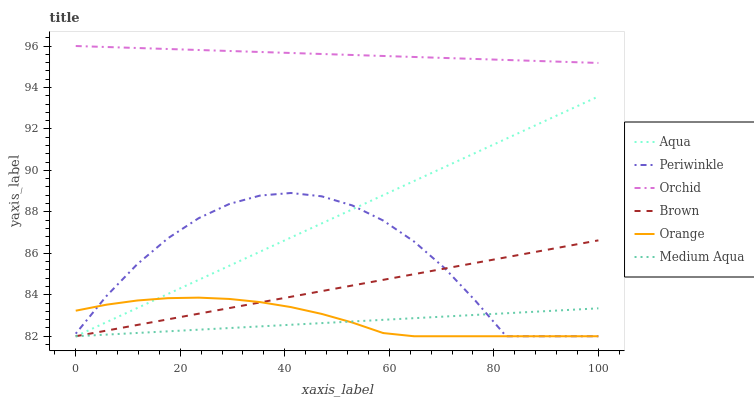Does Medium Aqua have the minimum area under the curve?
Answer yes or no. Yes. Does Orchid have the maximum area under the curve?
Answer yes or no. Yes. Does Aqua have the minimum area under the curve?
Answer yes or no. No. Does Aqua have the maximum area under the curve?
Answer yes or no. No. Is Medium Aqua the smoothest?
Answer yes or no. Yes. Is Periwinkle the roughest?
Answer yes or no. Yes. Is Aqua the smoothest?
Answer yes or no. No. Is Aqua the roughest?
Answer yes or no. No. Does Orchid have the lowest value?
Answer yes or no. No. Does Aqua have the highest value?
Answer yes or no. No. Is Brown less than Orchid?
Answer yes or no. Yes. Is Orchid greater than Aqua?
Answer yes or no. Yes. Does Brown intersect Orchid?
Answer yes or no. No. 